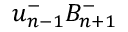<formula> <loc_0><loc_0><loc_500><loc_500>u _ { n - 1 } ^ { - } B _ { n + 1 } ^ { - }</formula> 